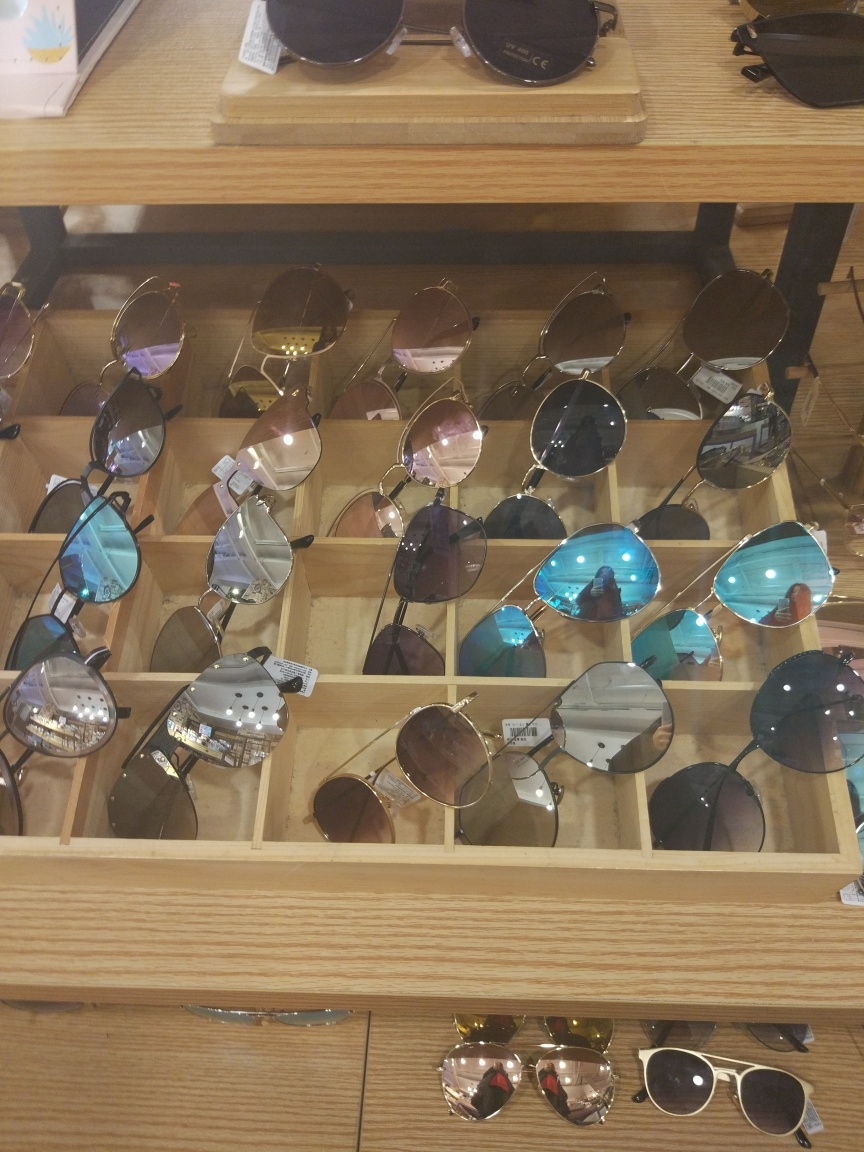Can you tell me what kind of sunglasses are displayed here? The display features a variety of sunglasses, including aviator, round, and oversized styles. There are both tinted and mirrored lenses, suitable for different preferences and face shapes. 